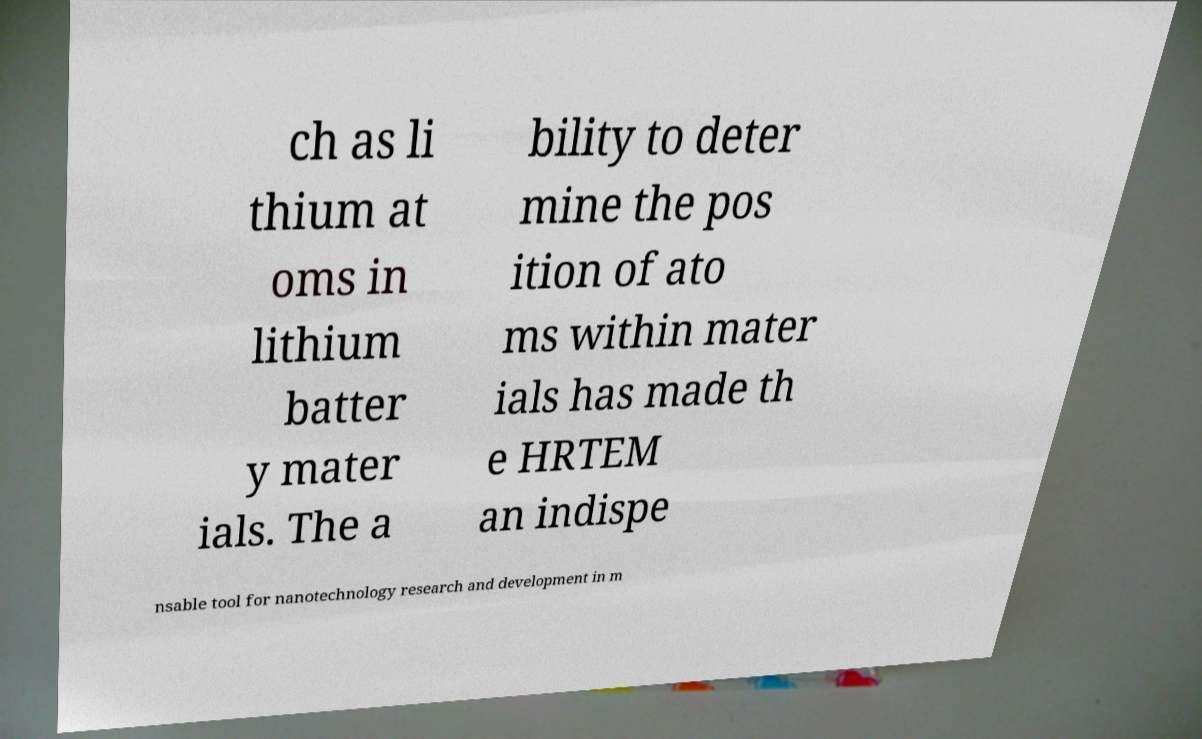What messages or text are displayed in this image? I need them in a readable, typed format. ch as li thium at oms in lithium batter y mater ials. The a bility to deter mine the pos ition of ato ms within mater ials has made th e HRTEM an indispe nsable tool for nanotechnology research and development in m 